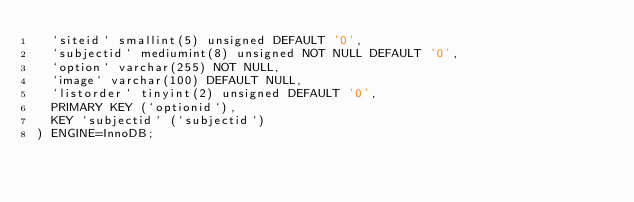Convert code to text. <code><loc_0><loc_0><loc_500><loc_500><_SQL_>  `siteid` smallint(5) unsigned DEFAULT '0',
  `subjectid` mediumint(8) unsigned NOT NULL DEFAULT '0',
  `option` varchar(255) NOT NULL,
  `image` varchar(100) DEFAULT NULL,
  `listorder` tinyint(2) unsigned DEFAULT '0',
  PRIMARY KEY (`optionid`),
  KEY `subjectid` (`subjectid`)
) ENGINE=InnoDB;</code> 